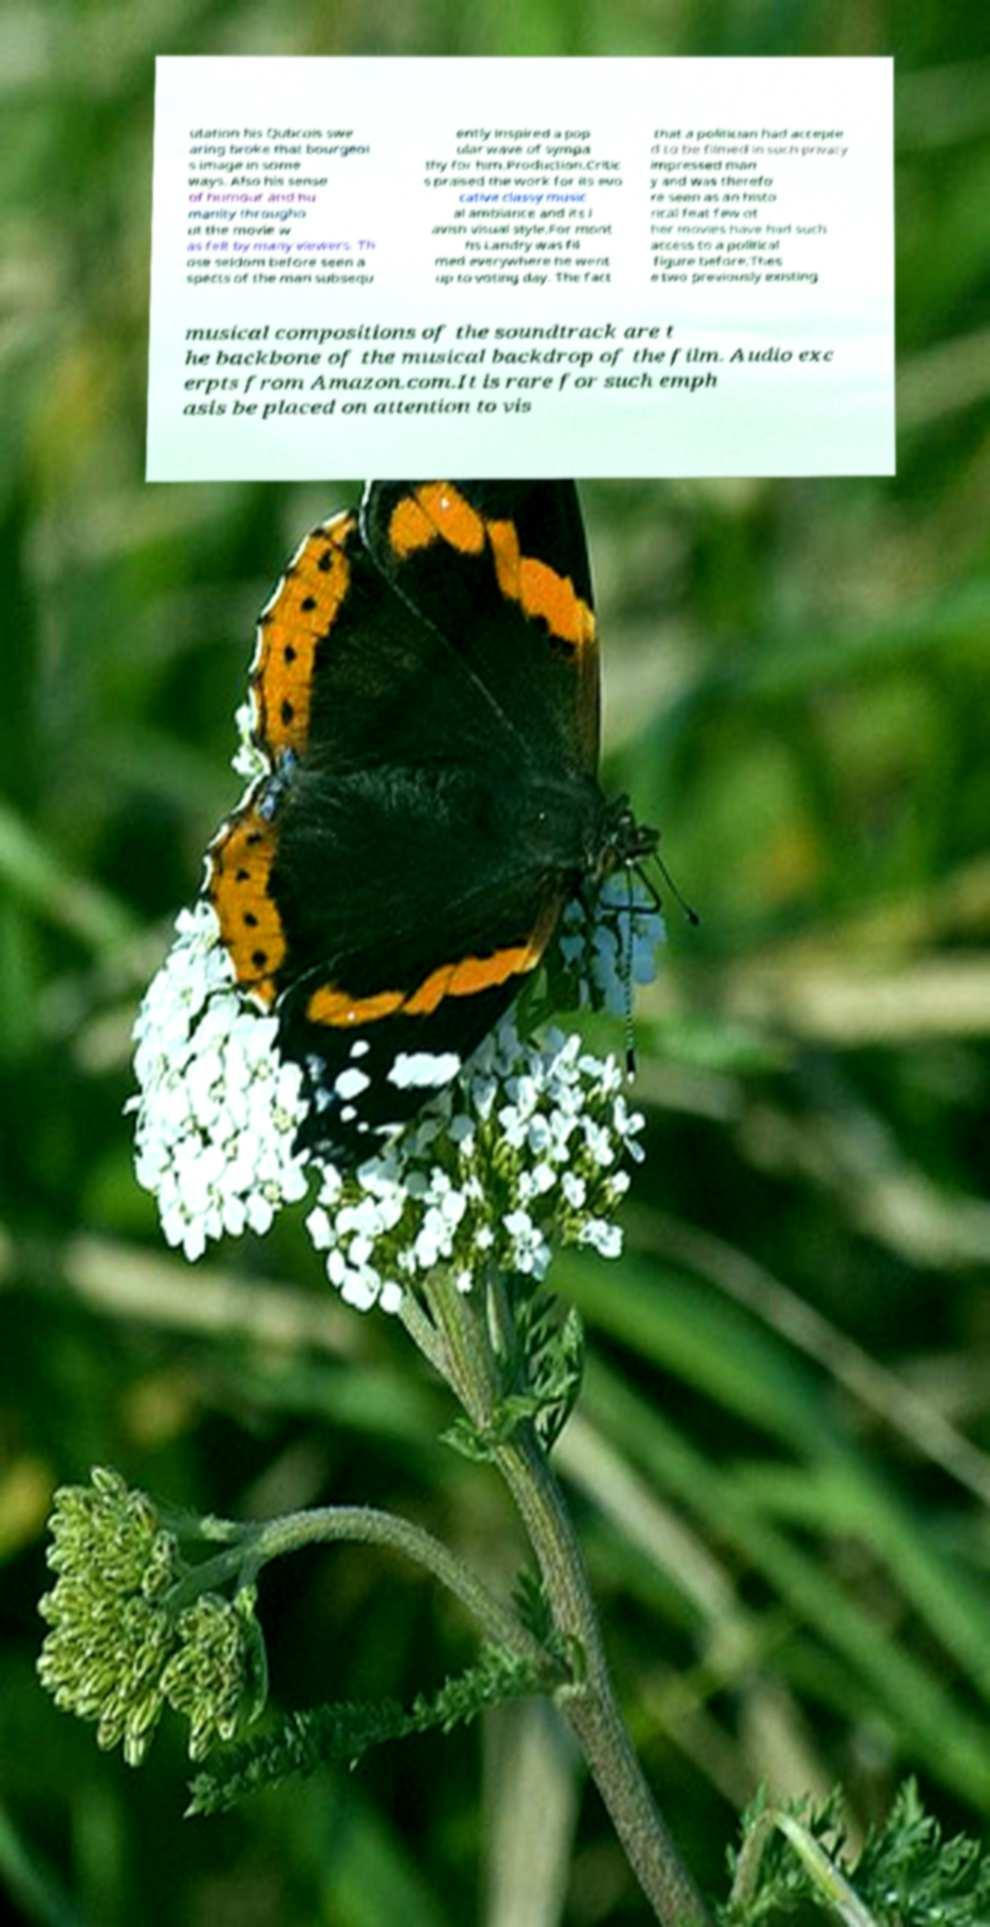What messages or text are displayed in this image? I need them in a readable, typed format. utation his Qubcois swe aring broke that bourgeoi s image in some ways. Also his sense of humour and hu manity througho ut the movie w as felt by many viewers. Th ose seldom before seen a spects of the man subsequ ently inspired a pop ular wave of sympa thy for him.Production.Critic s praised the work for its evo cative classy music al ambiance and its l avish visual style.For mont hs Landry was fil med everywhere he went up to voting day. The fact that a politician had accepte d to be filmed in such privacy impressed man y and was therefo re seen as an histo rical feat few ot her movies have had such access to a political figure before.Thes e two previously existing musical compositions of the soundtrack are t he backbone of the musical backdrop of the film. Audio exc erpts from Amazon.com.It is rare for such emph asis be placed on attention to vis 